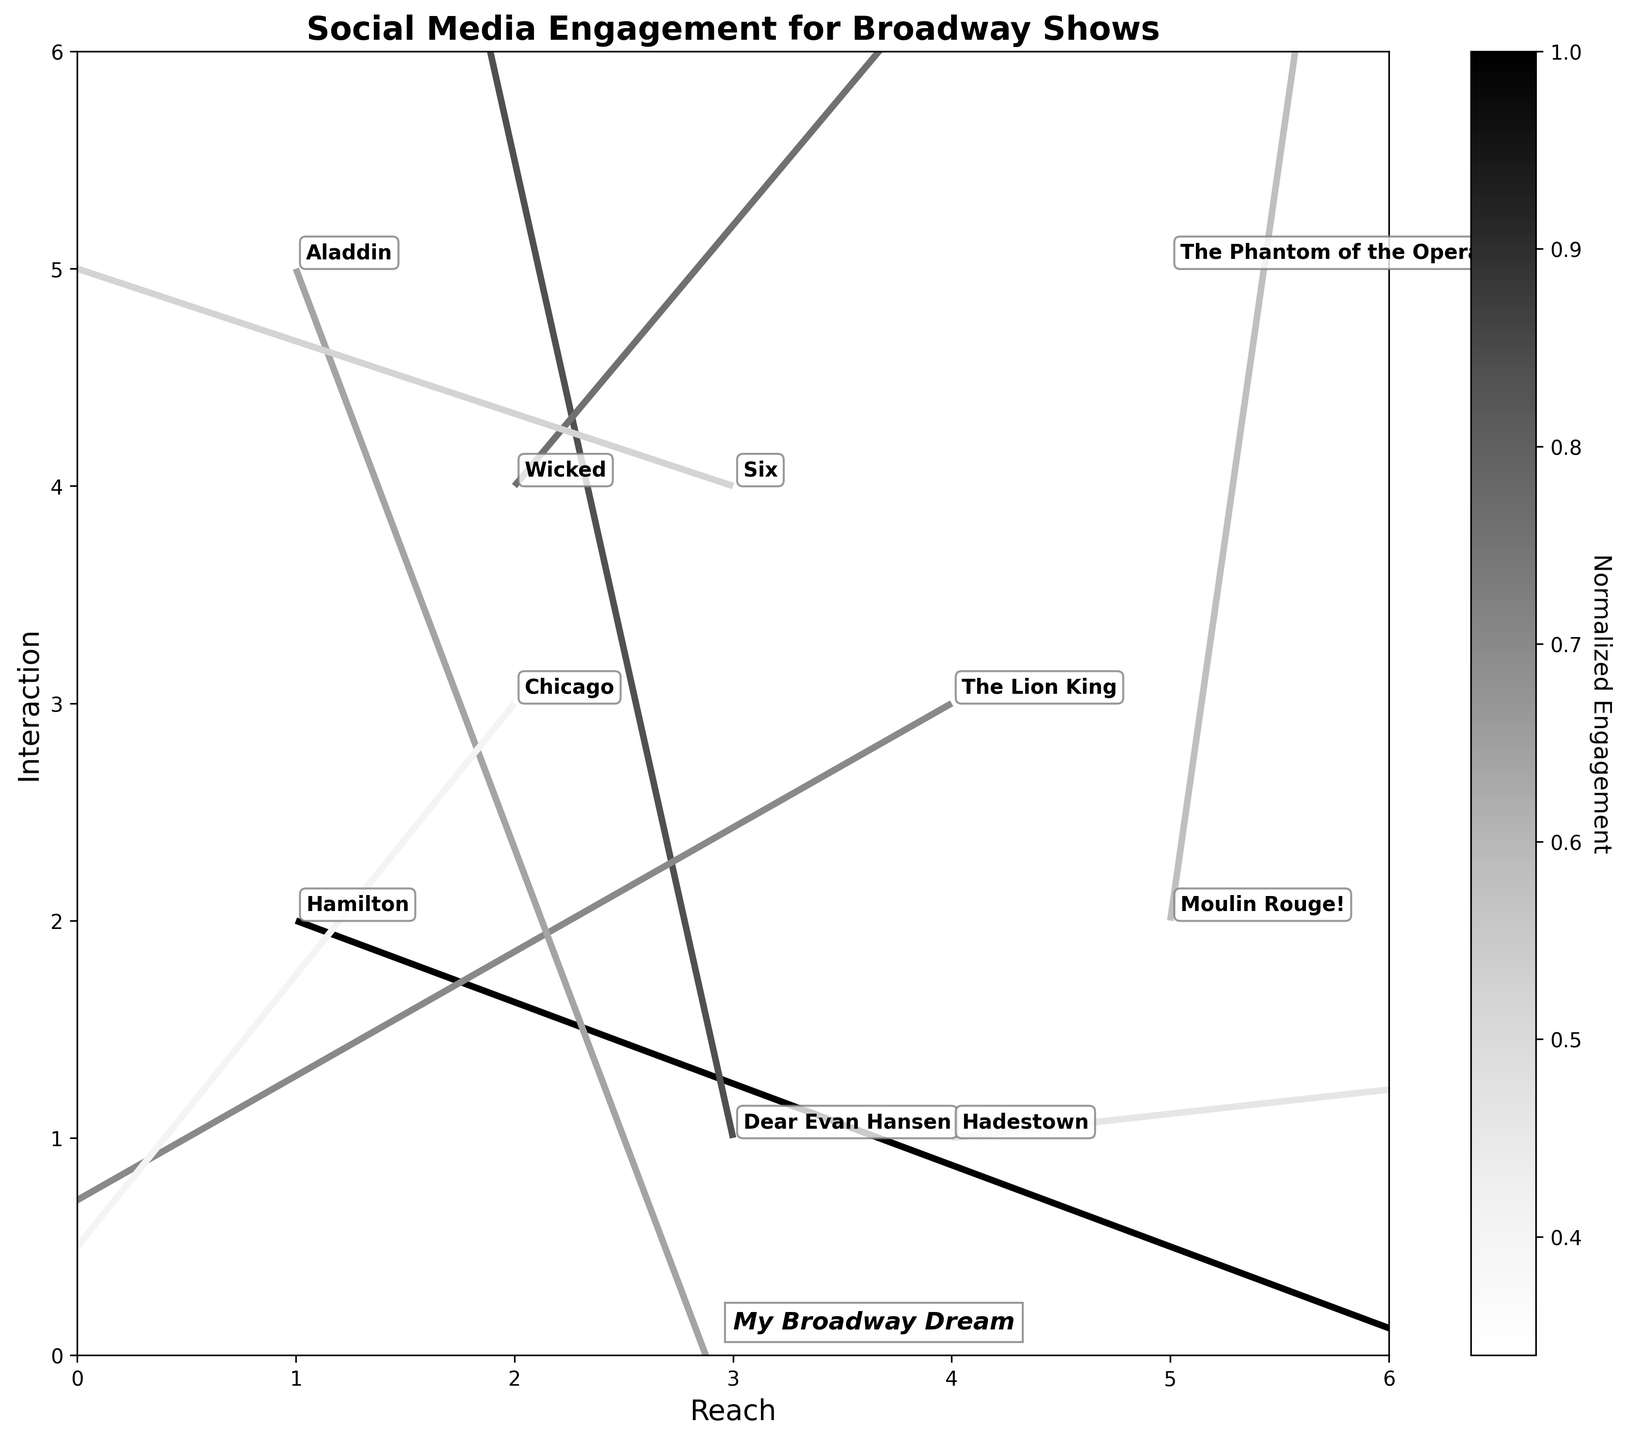What's the title of the figure? The title of the figure is typically displayed at the top and summarizes the main topic of the plot. Here, it is clearly shown as 'Social Media Engagement for Broadway Shows'.
Answer: Social Media Engagement for Broadway Shows Which Broadway show has the highest engagement magnitude? To find the highest engagement magnitude, we look for the largest value in the magnitude column represented by the longest arrow in the plot. 'Hamilton' has the highest magnitude at 5000.
Answer: Hamilton What axes labels are used in the figure? Axis labels are displayed along the x-axis and y-axis to indicate what each axis represents. In this figure, the x-axis is labeled 'Reach' and the y-axis is labeled 'Interaction'.
Answer: Reach and Interaction Between 'Hamilton' and 'The Lion King', which show has a greater reach direction (x-component)? The x-component (u) indicates the direction of reach. 'Hamilton' has a reach direction of 0.8, while 'The Lion King' has -0.7. Since 0.8 is greater than -0.7, 'Hamilton' has a greater reach direction.
Answer: Hamilton Which show has the smallest engagement magnitude and what is its value? By looking at the shortest arrow and the smallest value in the magnitude column, we see that 'The Phantom of the Opera' has the smallest engagement magnitude at 1700.
Answer: The Phantom of the Opera, 1700 How many Broadway shows are represented in the plot? The number of Broadway shows is given by the number of unique data points, which can also be counted from the show names annotated on the plot. There are 10 shows in total.
Answer: 10 Comparing 'Aladdin' and 'Hadestown', which show has a more negative interaction direction (y-component)? The y-component (v) indicates the direction of interaction. 'Aladdin' has -0.8, and 'Hadestown' has 0.1. Since -0.8 is more negative than 0.1, 'Aladdin' has a more negative interaction direction.
Answer: Aladdin Which Broadway show is closest to the coordinate (2, 3) in terms of reach and interaction? The show located at coordinates (2,3) is 'Chicago', as annotated on the plot.
Answer: Chicago How does the plot indicate normalized engagement, and what does the colorbar represent? The plot uses arrow sizes and shades to indicate normalized engagement. The colorbar on the right shows this normalized engagement, with lighter shades for higher normalized values.
Answer: Arrow size and color shading represent normalized engagement 